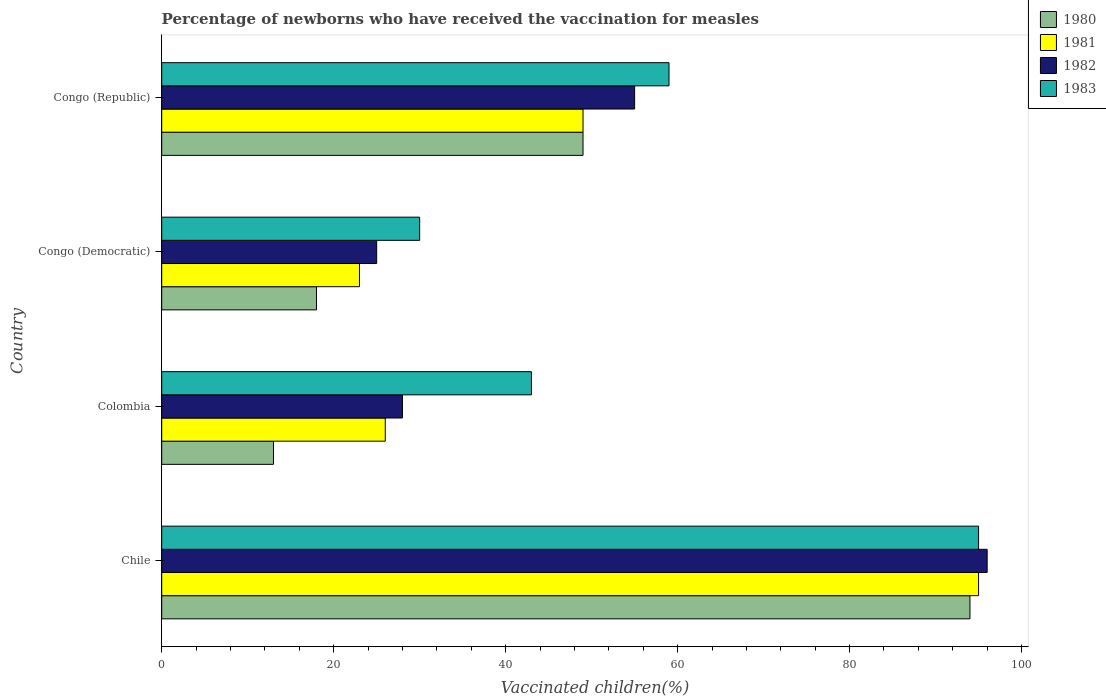How many groups of bars are there?
Provide a short and direct response. 4. Are the number of bars on each tick of the Y-axis equal?
Ensure brevity in your answer.  Yes. What is the label of the 4th group of bars from the top?
Offer a very short reply. Chile. In how many cases, is the number of bars for a given country not equal to the number of legend labels?
Keep it short and to the point. 0. What is the percentage of vaccinated children in 1983 in Chile?
Provide a succinct answer. 95. Across all countries, what is the maximum percentage of vaccinated children in 1981?
Keep it short and to the point. 95. What is the total percentage of vaccinated children in 1983 in the graph?
Keep it short and to the point. 227. What is the difference between the percentage of vaccinated children in 1983 in Chile and that in Congo (Democratic)?
Keep it short and to the point. 65. What is the difference between the percentage of vaccinated children in 1982 in Chile and the percentage of vaccinated children in 1981 in Colombia?
Provide a succinct answer. 70. What is the average percentage of vaccinated children in 1981 per country?
Offer a very short reply. 48.25. What is the ratio of the percentage of vaccinated children in 1982 in Chile to that in Congo (Democratic)?
Provide a short and direct response. 3.84. Is the percentage of vaccinated children in 1980 in Colombia less than that in Congo (Democratic)?
Give a very brief answer. Yes. What is the difference between the highest and the second highest percentage of vaccinated children in 1983?
Your answer should be very brief. 36. What is the difference between the highest and the lowest percentage of vaccinated children in 1983?
Offer a very short reply. 65. In how many countries, is the percentage of vaccinated children in 1980 greater than the average percentage of vaccinated children in 1980 taken over all countries?
Give a very brief answer. 2. Is it the case that in every country, the sum of the percentage of vaccinated children in 1982 and percentage of vaccinated children in 1983 is greater than the sum of percentage of vaccinated children in 1981 and percentage of vaccinated children in 1980?
Give a very brief answer. No. How many bars are there?
Provide a succinct answer. 16. Are all the bars in the graph horizontal?
Make the answer very short. Yes. How many countries are there in the graph?
Your answer should be very brief. 4. What is the difference between two consecutive major ticks on the X-axis?
Offer a terse response. 20. Does the graph contain any zero values?
Provide a short and direct response. No. Does the graph contain grids?
Your answer should be very brief. No. Where does the legend appear in the graph?
Offer a terse response. Top right. How many legend labels are there?
Ensure brevity in your answer.  4. How are the legend labels stacked?
Keep it short and to the point. Vertical. What is the title of the graph?
Your answer should be very brief. Percentage of newborns who have received the vaccination for measles. What is the label or title of the X-axis?
Offer a terse response. Vaccinated children(%). What is the label or title of the Y-axis?
Offer a terse response. Country. What is the Vaccinated children(%) in 1980 in Chile?
Make the answer very short. 94. What is the Vaccinated children(%) of 1982 in Chile?
Provide a short and direct response. 96. What is the Vaccinated children(%) of 1983 in Chile?
Your answer should be very brief. 95. What is the Vaccinated children(%) of 1980 in Colombia?
Provide a short and direct response. 13. What is the Vaccinated children(%) of 1982 in Colombia?
Ensure brevity in your answer.  28. What is the Vaccinated children(%) in 1980 in Congo (Democratic)?
Offer a very short reply. 18. What is the Vaccinated children(%) of 1981 in Congo (Democratic)?
Give a very brief answer. 23. What is the Vaccinated children(%) in 1981 in Congo (Republic)?
Provide a short and direct response. 49. Across all countries, what is the maximum Vaccinated children(%) of 1980?
Offer a terse response. 94. Across all countries, what is the maximum Vaccinated children(%) of 1982?
Keep it short and to the point. 96. Across all countries, what is the minimum Vaccinated children(%) of 1980?
Make the answer very short. 13. Across all countries, what is the minimum Vaccinated children(%) in 1982?
Give a very brief answer. 25. What is the total Vaccinated children(%) of 1980 in the graph?
Your response must be concise. 174. What is the total Vaccinated children(%) of 1981 in the graph?
Provide a succinct answer. 193. What is the total Vaccinated children(%) of 1982 in the graph?
Your answer should be compact. 204. What is the total Vaccinated children(%) of 1983 in the graph?
Provide a succinct answer. 227. What is the difference between the Vaccinated children(%) of 1982 in Chile and that in Colombia?
Provide a short and direct response. 68. What is the difference between the Vaccinated children(%) of 1981 in Chile and that in Congo (Democratic)?
Offer a very short reply. 72. What is the difference between the Vaccinated children(%) of 1983 in Chile and that in Congo (Democratic)?
Ensure brevity in your answer.  65. What is the difference between the Vaccinated children(%) in 1981 in Chile and that in Congo (Republic)?
Offer a very short reply. 46. What is the difference between the Vaccinated children(%) in 1980 in Colombia and that in Congo (Democratic)?
Your answer should be compact. -5. What is the difference between the Vaccinated children(%) of 1982 in Colombia and that in Congo (Democratic)?
Give a very brief answer. 3. What is the difference between the Vaccinated children(%) of 1983 in Colombia and that in Congo (Democratic)?
Your answer should be very brief. 13. What is the difference between the Vaccinated children(%) of 1980 in Colombia and that in Congo (Republic)?
Provide a short and direct response. -36. What is the difference between the Vaccinated children(%) in 1981 in Colombia and that in Congo (Republic)?
Keep it short and to the point. -23. What is the difference between the Vaccinated children(%) in 1982 in Colombia and that in Congo (Republic)?
Offer a terse response. -27. What is the difference between the Vaccinated children(%) of 1980 in Congo (Democratic) and that in Congo (Republic)?
Make the answer very short. -31. What is the difference between the Vaccinated children(%) in 1982 in Congo (Democratic) and that in Congo (Republic)?
Offer a terse response. -30. What is the difference between the Vaccinated children(%) in 1983 in Congo (Democratic) and that in Congo (Republic)?
Provide a short and direct response. -29. What is the difference between the Vaccinated children(%) of 1980 in Chile and the Vaccinated children(%) of 1983 in Colombia?
Your response must be concise. 51. What is the difference between the Vaccinated children(%) in 1981 in Chile and the Vaccinated children(%) in 1983 in Colombia?
Keep it short and to the point. 52. What is the difference between the Vaccinated children(%) in 1982 in Chile and the Vaccinated children(%) in 1983 in Colombia?
Offer a terse response. 53. What is the difference between the Vaccinated children(%) in 1980 in Chile and the Vaccinated children(%) in 1983 in Congo (Democratic)?
Offer a very short reply. 64. What is the difference between the Vaccinated children(%) in 1982 in Chile and the Vaccinated children(%) in 1983 in Congo (Democratic)?
Make the answer very short. 66. What is the difference between the Vaccinated children(%) of 1981 in Chile and the Vaccinated children(%) of 1982 in Congo (Republic)?
Your response must be concise. 40. What is the difference between the Vaccinated children(%) in 1981 in Chile and the Vaccinated children(%) in 1983 in Congo (Republic)?
Ensure brevity in your answer.  36. What is the difference between the Vaccinated children(%) in 1982 in Chile and the Vaccinated children(%) in 1983 in Congo (Republic)?
Your answer should be very brief. 37. What is the difference between the Vaccinated children(%) of 1980 in Colombia and the Vaccinated children(%) of 1983 in Congo (Democratic)?
Offer a terse response. -17. What is the difference between the Vaccinated children(%) in 1981 in Colombia and the Vaccinated children(%) in 1982 in Congo (Democratic)?
Provide a succinct answer. 1. What is the difference between the Vaccinated children(%) in 1981 in Colombia and the Vaccinated children(%) in 1983 in Congo (Democratic)?
Your answer should be very brief. -4. What is the difference between the Vaccinated children(%) in 1980 in Colombia and the Vaccinated children(%) in 1981 in Congo (Republic)?
Give a very brief answer. -36. What is the difference between the Vaccinated children(%) of 1980 in Colombia and the Vaccinated children(%) of 1982 in Congo (Republic)?
Offer a terse response. -42. What is the difference between the Vaccinated children(%) in 1980 in Colombia and the Vaccinated children(%) in 1983 in Congo (Republic)?
Your answer should be very brief. -46. What is the difference between the Vaccinated children(%) in 1981 in Colombia and the Vaccinated children(%) in 1983 in Congo (Republic)?
Your response must be concise. -33. What is the difference between the Vaccinated children(%) of 1982 in Colombia and the Vaccinated children(%) of 1983 in Congo (Republic)?
Offer a terse response. -31. What is the difference between the Vaccinated children(%) of 1980 in Congo (Democratic) and the Vaccinated children(%) of 1981 in Congo (Republic)?
Offer a terse response. -31. What is the difference between the Vaccinated children(%) in 1980 in Congo (Democratic) and the Vaccinated children(%) in 1982 in Congo (Republic)?
Your response must be concise. -37. What is the difference between the Vaccinated children(%) in 1980 in Congo (Democratic) and the Vaccinated children(%) in 1983 in Congo (Republic)?
Ensure brevity in your answer.  -41. What is the difference between the Vaccinated children(%) in 1981 in Congo (Democratic) and the Vaccinated children(%) in 1982 in Congo (Republic)?
Your response must be concise. -32. What is the difference between the Vaccinated children(%) of 1981 in Congo (Democratic) and the Vaccinated children(%) of 1983 in Congo (Republic)?
Give a very brief answer. -36. What is the difference between the Vaccinated children(%) in 1982 in Congo (Democratic) and the Vaccinated children(%) in 1983 in Congo (Republic)?
Ensure brevity in your answer.  -34. What is the average Vaccinated children(%) of 1980 per country?
Your response must be concise. 43.5. What is the average Vaccinated children(%) in 1981 per country?
Give a very brief answer. 48.25. What is the average Vaccinated children(%) in 1982 per country?
Offer a terse response. 51. What is the average Vaccinated children(%) in 1983 per country?
Offer a terse response. 56.75. What is the difference between the Vaccinated children(%) of 1980 and Vaccinated children(%) of 1981 in Chile?
Keep it short and to the point. -1. What is the difference between the Vaccinated children(%) of 1982 and Vaccinated children(%) of 1983 in Chile?
Make the answer very short. 1. What is the difference between the Vaccinated children(%) of 1980 and Vaccinated children(%) of 1982 in Congo (Democratic)?
Ensure brevity in your answer.  -7. What is the difference between the Vaccinated children(%) of 1981 and Vaccinated children(%) of 1982 in Congo (Democratic)?
Your answer should be very brief. -2. What is the difference between the Vaccinated children(%) of 1980 and Vaccinated children(%) of 1981 in Congo (Republic)?
Give a very brief answer. 0. What is the difference between the Vaccinated children(%) of 1980 and Vaccinated children(%) of 1982 in Congo (Republic)?
Provide a short and direct response. -6. What is the difference between the Vaccinated children(%) in 1980 and Vaccinated children(%) in 1983 in Congo (Republic)?
Ensure brevity in your answer.  -10. What is the difference between the Vaccinated children(%) of 1982 and Vaccinated children(%) of 1983 in Congo (Republic)?
Provide a short and direct response. -4. What is the ratio of the Vaccinated children(%) in 1980 in Chile to that in Colombia?
Ensure brevity in your answer.  7.23. What is the ratio of the Vaccinated children(%) in 1981 in Chile to that in Colombia?
Give a very brief answer. 3.65. What is the ratio of the Vaccinated children(%) of 1982 in Chile to that in Colombia?
Provide a succinct answer. 3.43. What is the ratio of the Vaccinated children(%) in 1983 in Chile to that in Colombia?
Offer a terse response. 2.21. What is the ratio of the Vaccinated children(%) of 1980 in Chile to that in Congo (Democratic)?
Provide a succinct answer. 5.22. What is the ratio of the Vaccinated children(%) of 1981 in Chile to that in Congo (Democratic)?
Keep it short and to the point. 4.13. What is the ratio of the Vaccinated children(%) of 1982 in Chile to that in Congo (Democratic)?
Provide a short and direct response. 3.84. What is the ratio of the Vaccinated children(%) in 1983 in Chile to that in Congo (Democratic)?
Give a very brief answer. 3.17. What is the ratio of the Vaccinated children(%) of 1980 in Chile to that in Congo (Republic)?
Make the answer very short. 1.92. What is the ratio of the Vaccinated children(%) of 1981 in Chile to that in Congo (Republic)?
Keep it short and to the point. 1.94. What is the ratio of the Vaccinated children(%) in 1982 in Chile to that in Congo (Republic)?
Ensure brevity in your answer.  1.75. What is the ratio of the Vaccinated children(%) of 1983 in Chile to that in Congo (Republic)?
Provide a short and direct response. 1.61. What is the ratio of the Vaccinated children(%) in 1980 in Colombia to that in Congo (Democratic)?
Offer a terse response. 0.72. What is the ratio of the Vaccinated children(%) of 1981 in Colombia to that in Congo (Democratic)?
Your response must be concise. 1.13. What is the ratio of the Vaccinated children(%) in 1982 in Colombia to that in Congo (Democratic)?
Make the answer very short. 1.12. What is the ratio of the Vaccinated children(%) of 1983 in Colombia to that in Congo (Democratic)?
Offer a terse response. 1.43. What is the ratio of the Vaccinated children(%) of 1980 in Colombia to that in Congo (Republic)?
Ensure brevity in your answer.  0.27. What is the ratio of the Vaccinated children(%) in 1981 in Colombia to that in Congo (Republic)?
Give a very brief answer. 0.53. What is the ratio of the Vaccinated children(%) in 1982 in Colombia to that in Congo (Republic)?
Your answer should be very brief. 0.51. What is the ratio of the Vaccinated children(%) in 1983 in Colombia to that in Congo (Republic)?
Make the answer very short. 0.73. What is the ratio of the Vaccinated children(%) in 1980 in Congo (Democratic) to that in Congo (Republic)?
Your answer should be compact. 0.37. What is the ratio of the Vaccinated children(%) of 1981 in Congo (Democratic) to that in Congo (Republic)?
Offer a terse response. 0.47. What is the ratio of the Vaccinated children(%) of 1982 in Congo (Democratic) to that in Congo (Republic)?
Offer a terse response. 0.45. What is the ratio of the Vaccinated children(%) of 1983 in Congo (Democratic) to that in Congo (Republic)?
Keep it short and to the point. 0.51. What is the difference between the highest and the second highest Vaccinated children(%) of 1982?
Your answer should be very brief. 41. What is the difference between the highest and the lowest Vaccinated children(%) of 1980?
Your answer should be compact. 81. What is the difference between the highest and the lowest Vaccinated children(%) of 1981?
Ensure brevity in your answer.  72. What is the difference between the highest and the lowest Vaccinated children(%) of 1982?
Your answer should be compact. 71. What is the difference between the highest and the lowest Vaccinated children(%) of 1983?
Your answer should be compact. 65. 